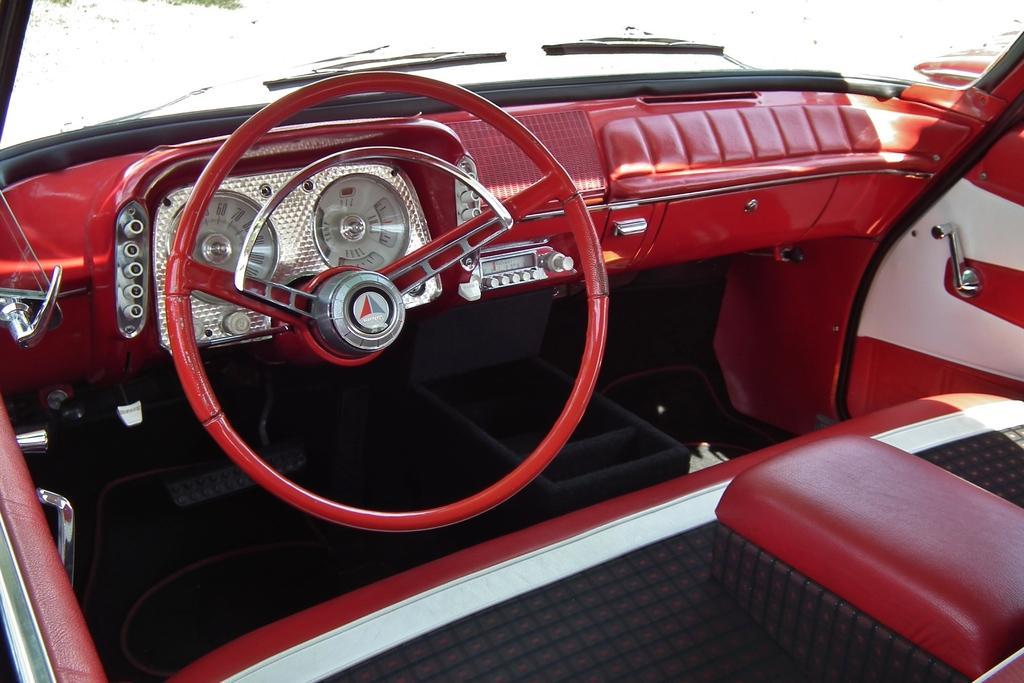Could you give a brief overview of what you see in this image? This is the inner view of a vehicle. In which, we can see there is a speedometer, a radio, doors, seats and front glass window. And the background of this interview is red in color. 